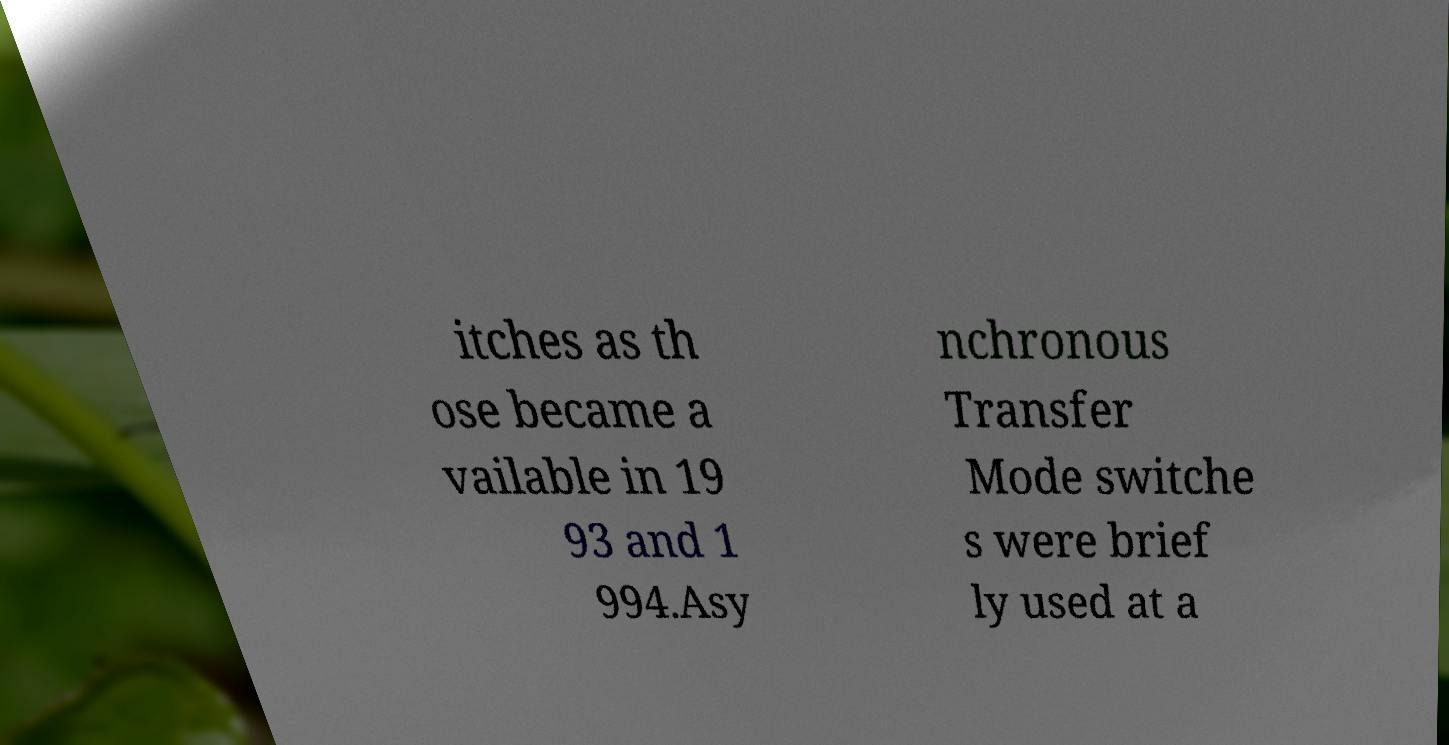There's text embedded in this image that I need extracted. Can you transcribe it verbatim? itches as th ose became a vailable in 19 93 and 1 994.Asy nchronous Transfer Mode switche s were brief ly used at a 